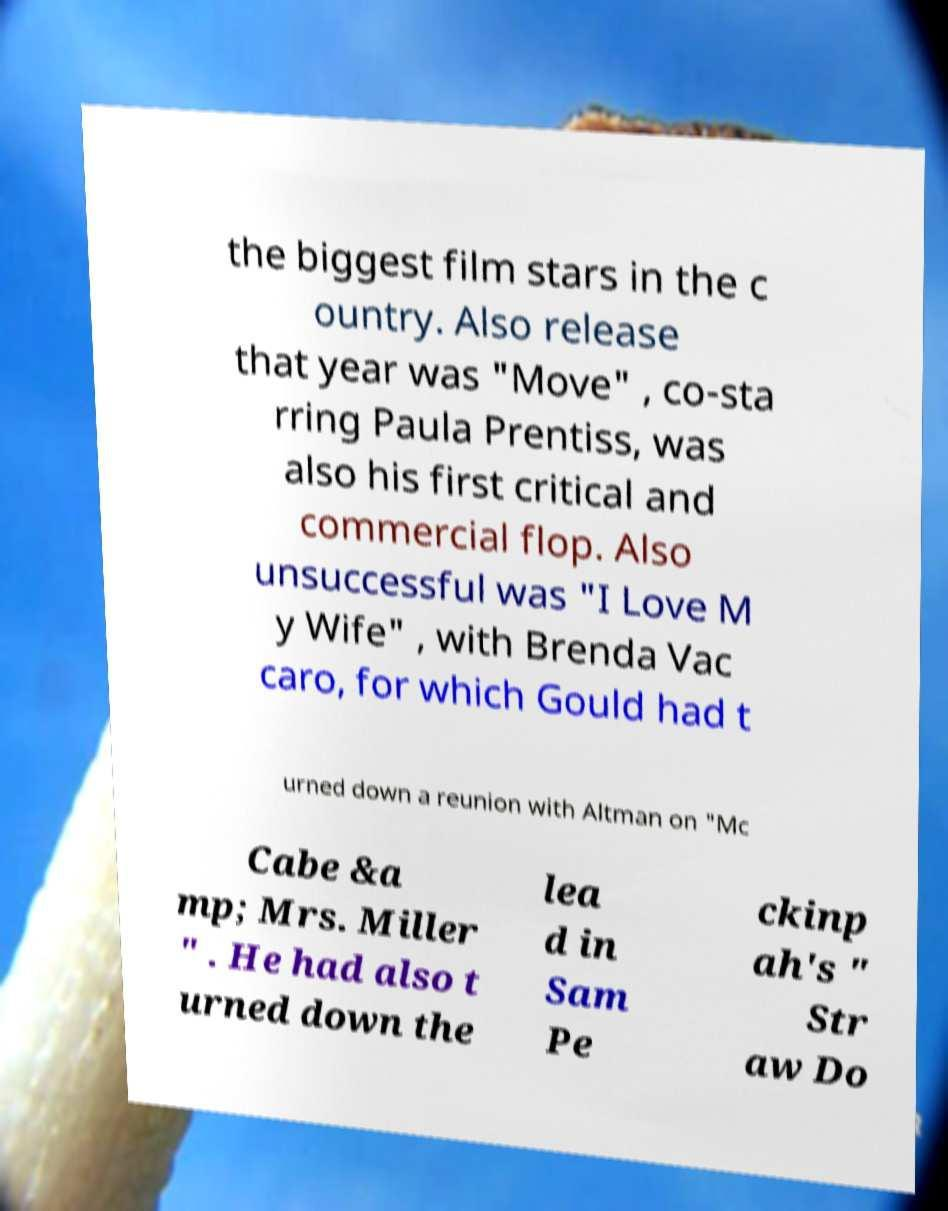Could you extract and type out the text from this image? the biggest film stars in the c ountry. Also release that year was "Move" , co-sta rring Paula Prentiss, was also his first critical and commercial flop. Also unsuccessful was "I Love M y Wife" , with Brenda Vac caro, for which Gould had t urned down a reunion with Altman on "Mc Cabe &a mp; Mrs. Miller " . He had also t urned down the lea d in Sam Pe ckinp ah's " Str aw Do 